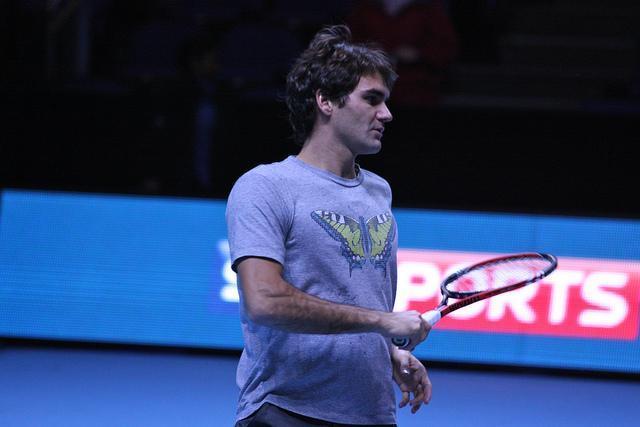How many plates have a sandwich on it?
Give a very brief answer. 0. 